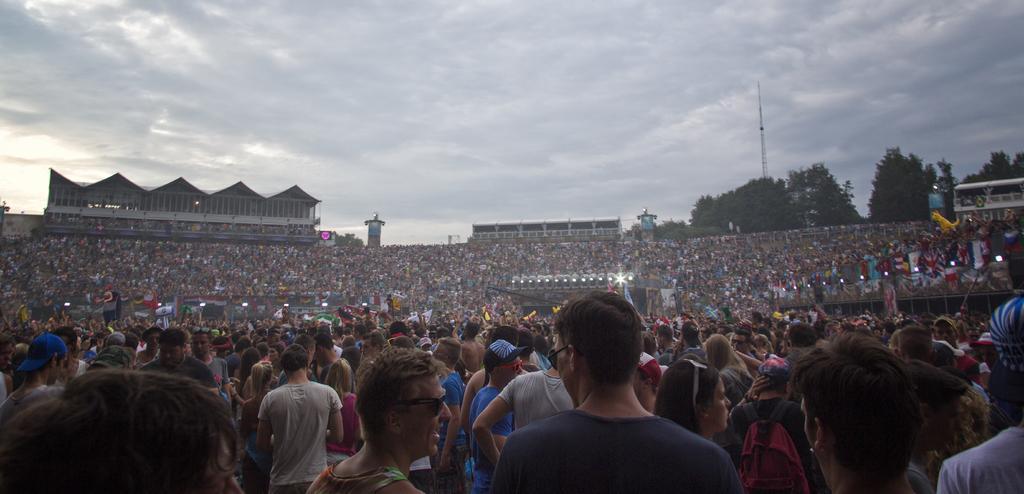How would you summarize this image in a sentence or two? There are many people. There is a stage at the center which has lights. There are trees, buildings and an electric pole at the back. 